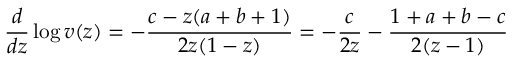<formula> <loc_0><loc_0><loc_500><loc_500>{ \frac { d } { d z } } \log v ( z ) = - { \frac { c - z ( a + b + 1 ) } { 2 z ( 1 - z ) } } = - { \frac { c } { 2 z } } - { \frac { 1 + a + b - c } { 2 ( z - 1 ) } }</formula> 